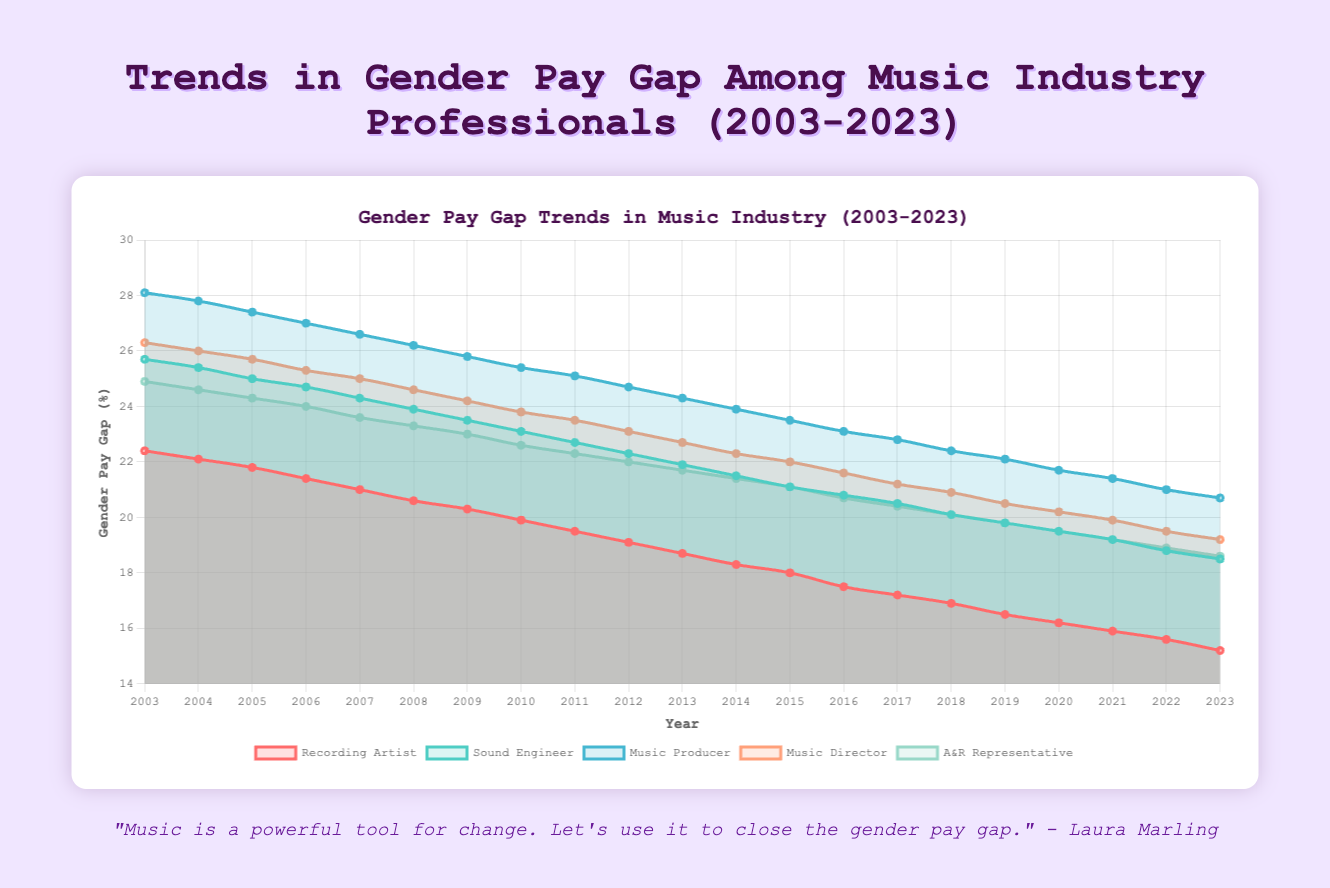What's the general trend in the gender pay gap for Recording Artists from 2003 to 2023? The trend in the gender pay gap for Recording Artists shows a clear decrease over the years. In 2003, it starts at 22.4%, and by 2023, it has reduced to 15.2%. This indicates progress towards narrowing the pay gap.
Answer: Decreasing Which job title had the highest gender pay gap percentage in 2003? To determine this, compare the percentage gaps for all job titles in 2003. Recording Artists had a gap of 22.4%, Sound Engineers had 25.7%, Music Producers had 28.1%, Music Directors had 26.3%, and A&R Representatives had 24.9%. The highest is for Music Producers at 28.1%.
Answer: Music Producers By how many percentage points did the gender pay gap decrease for Sound Engineers from 2003 to 2023? In 2003, the pay gap for Sound Engineers was 25.7%, and in 2023, it was 18.5%. The decrease is calculated as 25.7% - 18.5% = 7.2%.
Answer: 7.2 Which job title shows the least reduction in the gender pay gap over the 20 years? Calculate the reduction for each job title by finding the difference between the 2003 and 2023 values. Recording Artists reduced by 22.4 - 15.2 = 7.2, Sound Engineers by 25.7 - 18.5 = 7.2, Music Producers by 28.1 - 20.7 = 7.4, Music Directors by 26.3 - 19.2 = 7.1, and A&R Representatives by 24.9 - 18.6 = 6.3. The smallest reduction is for A&R Representatives.
Answer: A&R Representatives In which year did the gender pay gap for Music Directors drop below 20% for the first time? Examine the data points for Music Directors annually and find the first year when the value is below 20%. The gap is 19.9% in 2021, marking the first instance below 20%.
Answer: 2021 What is the average gender pay gap for Music Producers over the first 10 years (2003-2012)? Average is calculated by summing the pay gaps for the first 10 years and dividing by the number of years. Sum: 28.1 + 27.8 + 27.4 + 27.0 + 26.6 + 26.2 + 25.8 + 25.4 + 25.1 + 24.7 = 264.1. Average = 264.1 / 10 = 26.41.
Answer: 26.41 In which job title does the gender pay gap remain consistently higher than others throughout the 20 years? Refer to the plotted data lines for all job titles. The Music Producers’ pay gap remains highest compared to others every year.
Answer: Music Producers What is the difference in gender pay gap percentages between Recording Artists and A&R Representatives in 2010? Check the values for both job titles in 2010. Recording Artists had a 19.9% gap and A&R Representatives had a 22.6% gap in 2010. The difference is 22.6% - 19.9% = 2.7%.
Answer: 2.7 Which job positions had their pay gaps reduced to below 20% before 2020? Evaluate the trends for each job title and check years around 2019. Recording Artists (before 2020), Sound Engineers (before 2020), Music Producers (before 2020), and Music Directors (before 2020) all achieved below 20% before 2020, but A&R Representatives did not achieve below 20% until 2022.
Answer: Recording Artists, Sound Engineers, Music Producers, and Music Directors 